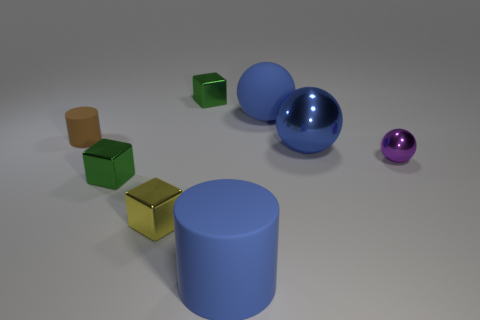What number of blocks are right of the small metallic sphere?
Your answer should be very brief. 0. Does the purple object have the same material as the big blue object behind the tiny brown object?
Make the answer very short. No. Are there any yellow matte spheres of the same size as the blue cylinder?
Ensure brevity in your answer.  No. Are there an equal number of rubber cylinders that are behind the brown cylinder and blue objects?
Make the answer very short. No. How big is the purple shiny thing?
Provide a short and direct response. Small. What number of rubber cylinders are on the left side of the tiny green object behind the large blue metal thing?
Your response must be concise. 1. What is the shape of the tiny shiny object that is right of the small yellow block and in front of the small brown rubber thing?
Your answer should be compact. Sphere. How many matte things are the same color as the big metallic thing?
Keep it short and to the point. 2. Is there a big blue rubber object that is left of the blue ball behind the big blue sphere that is in front of the small brown object?
Make the answer very short. Yes. There is a thing that is both left of the blue rubber cylinder and behind the tiny brown cylinder; what size is it?
Ensure brevity in your answer.  Small. 